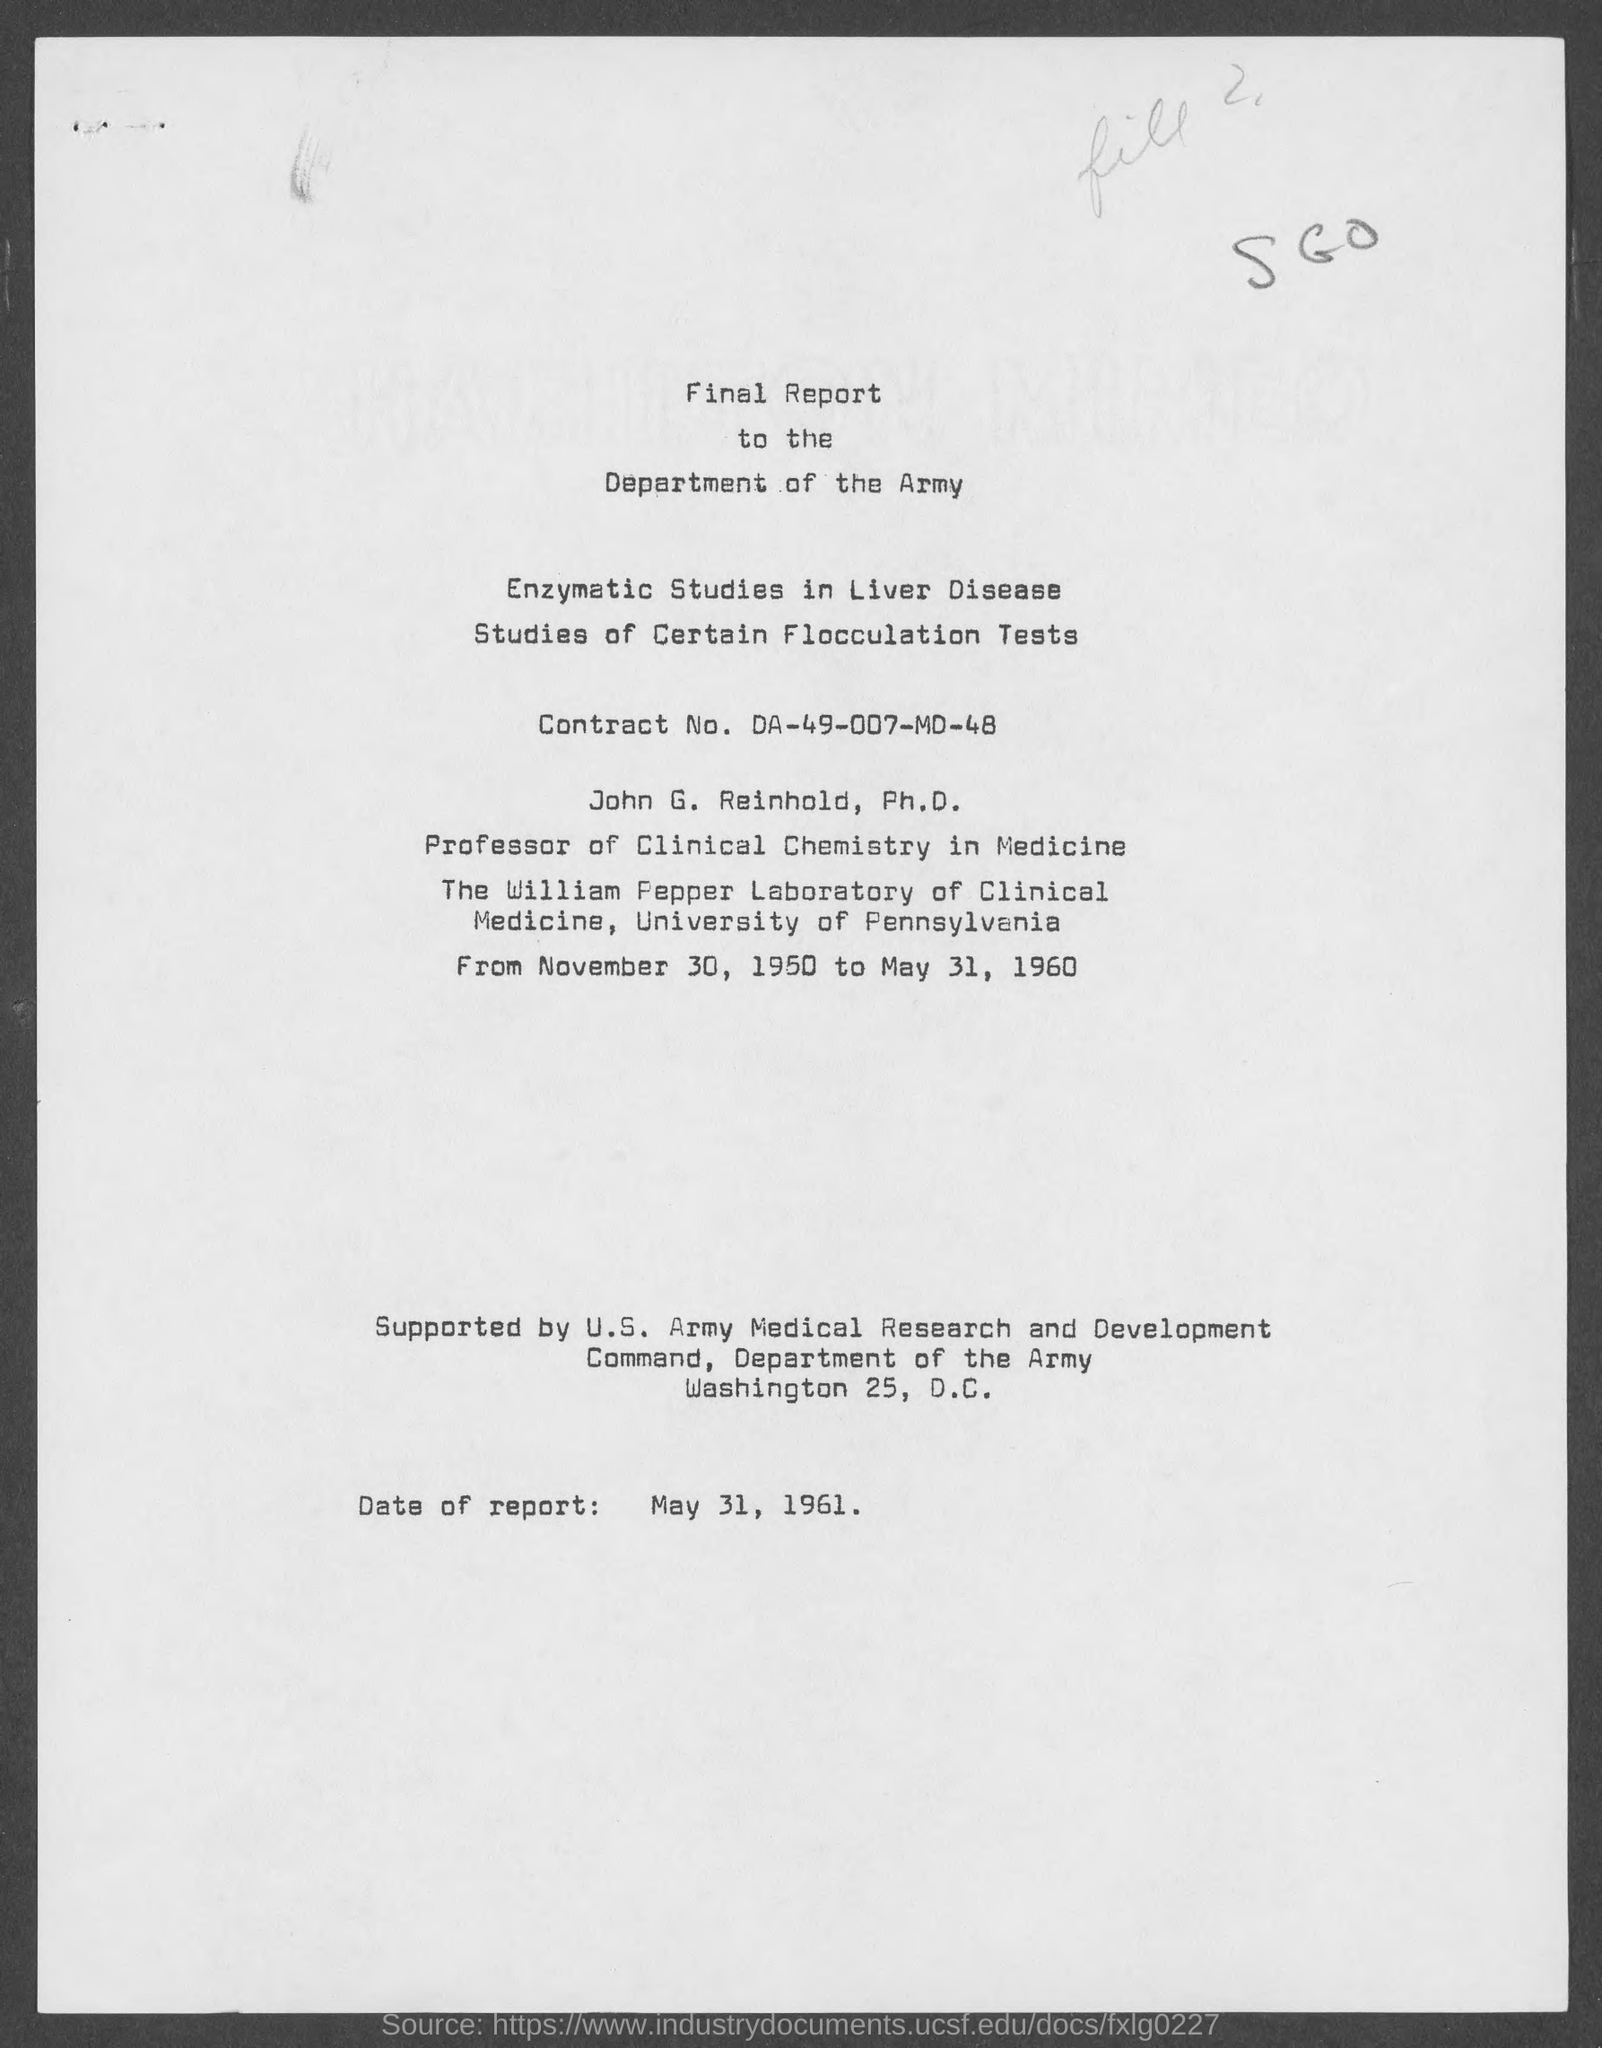What is the date of the report given in the dcument?
Your answer should be compact. May 31, 1961. 